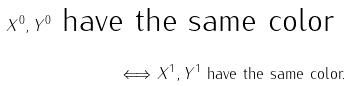<formula> <loc_0><loc_0><loc_500><loc_500>X ^ { 0 } , Y ^ { 0 } \text { have the same color } \\ \Longleftrightarrow X ^ { 1 } , Y ^ { 1 } \text { have the same color.}</formula> 